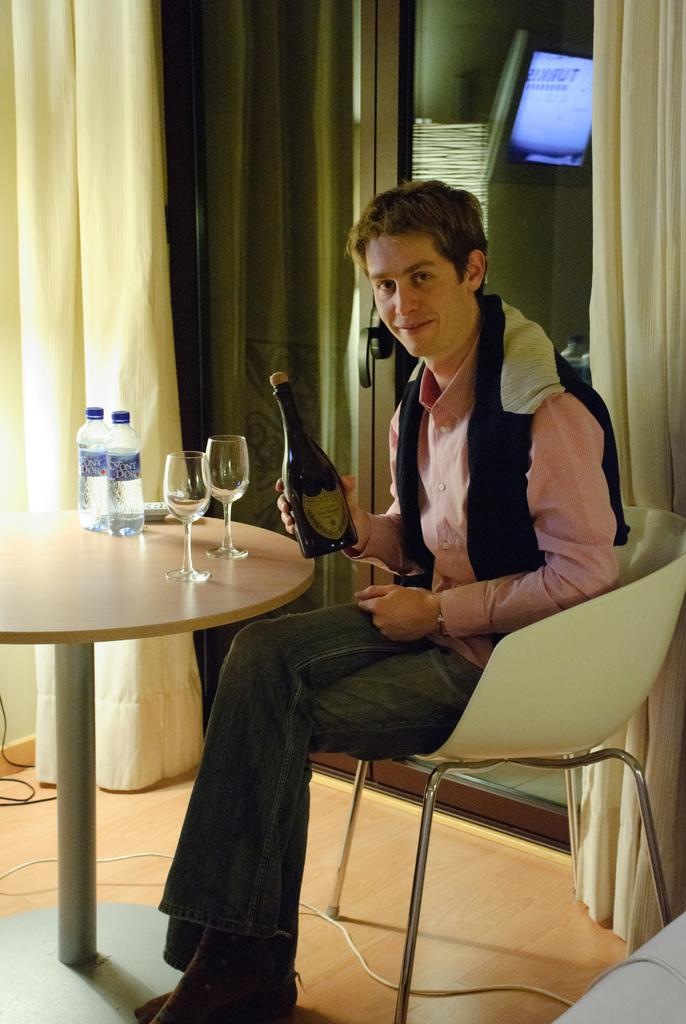What color is the curtain in the image? The curtain in the image is yellow. What can be seen on the wall in the image? There is a screen in the image. What is the man in the image doing? The man is sitting on a chair in the image. What is on the table in the image? There are bottles, a remote, and glasses on the table in the image. What type of fish is swimming in the yellow curtain in the image? There is no fish present in the image, and the yellow curtain is not a body of water. How many tickets can be seen on the table in the image? There are no tickets present in the image. 